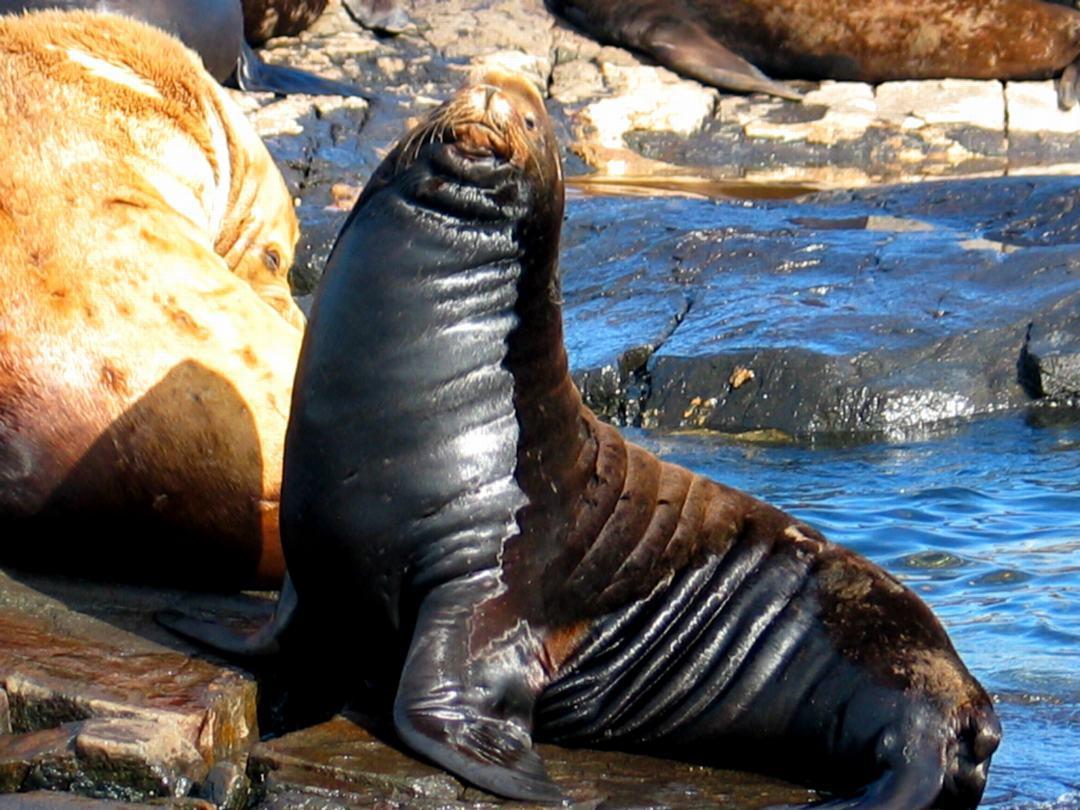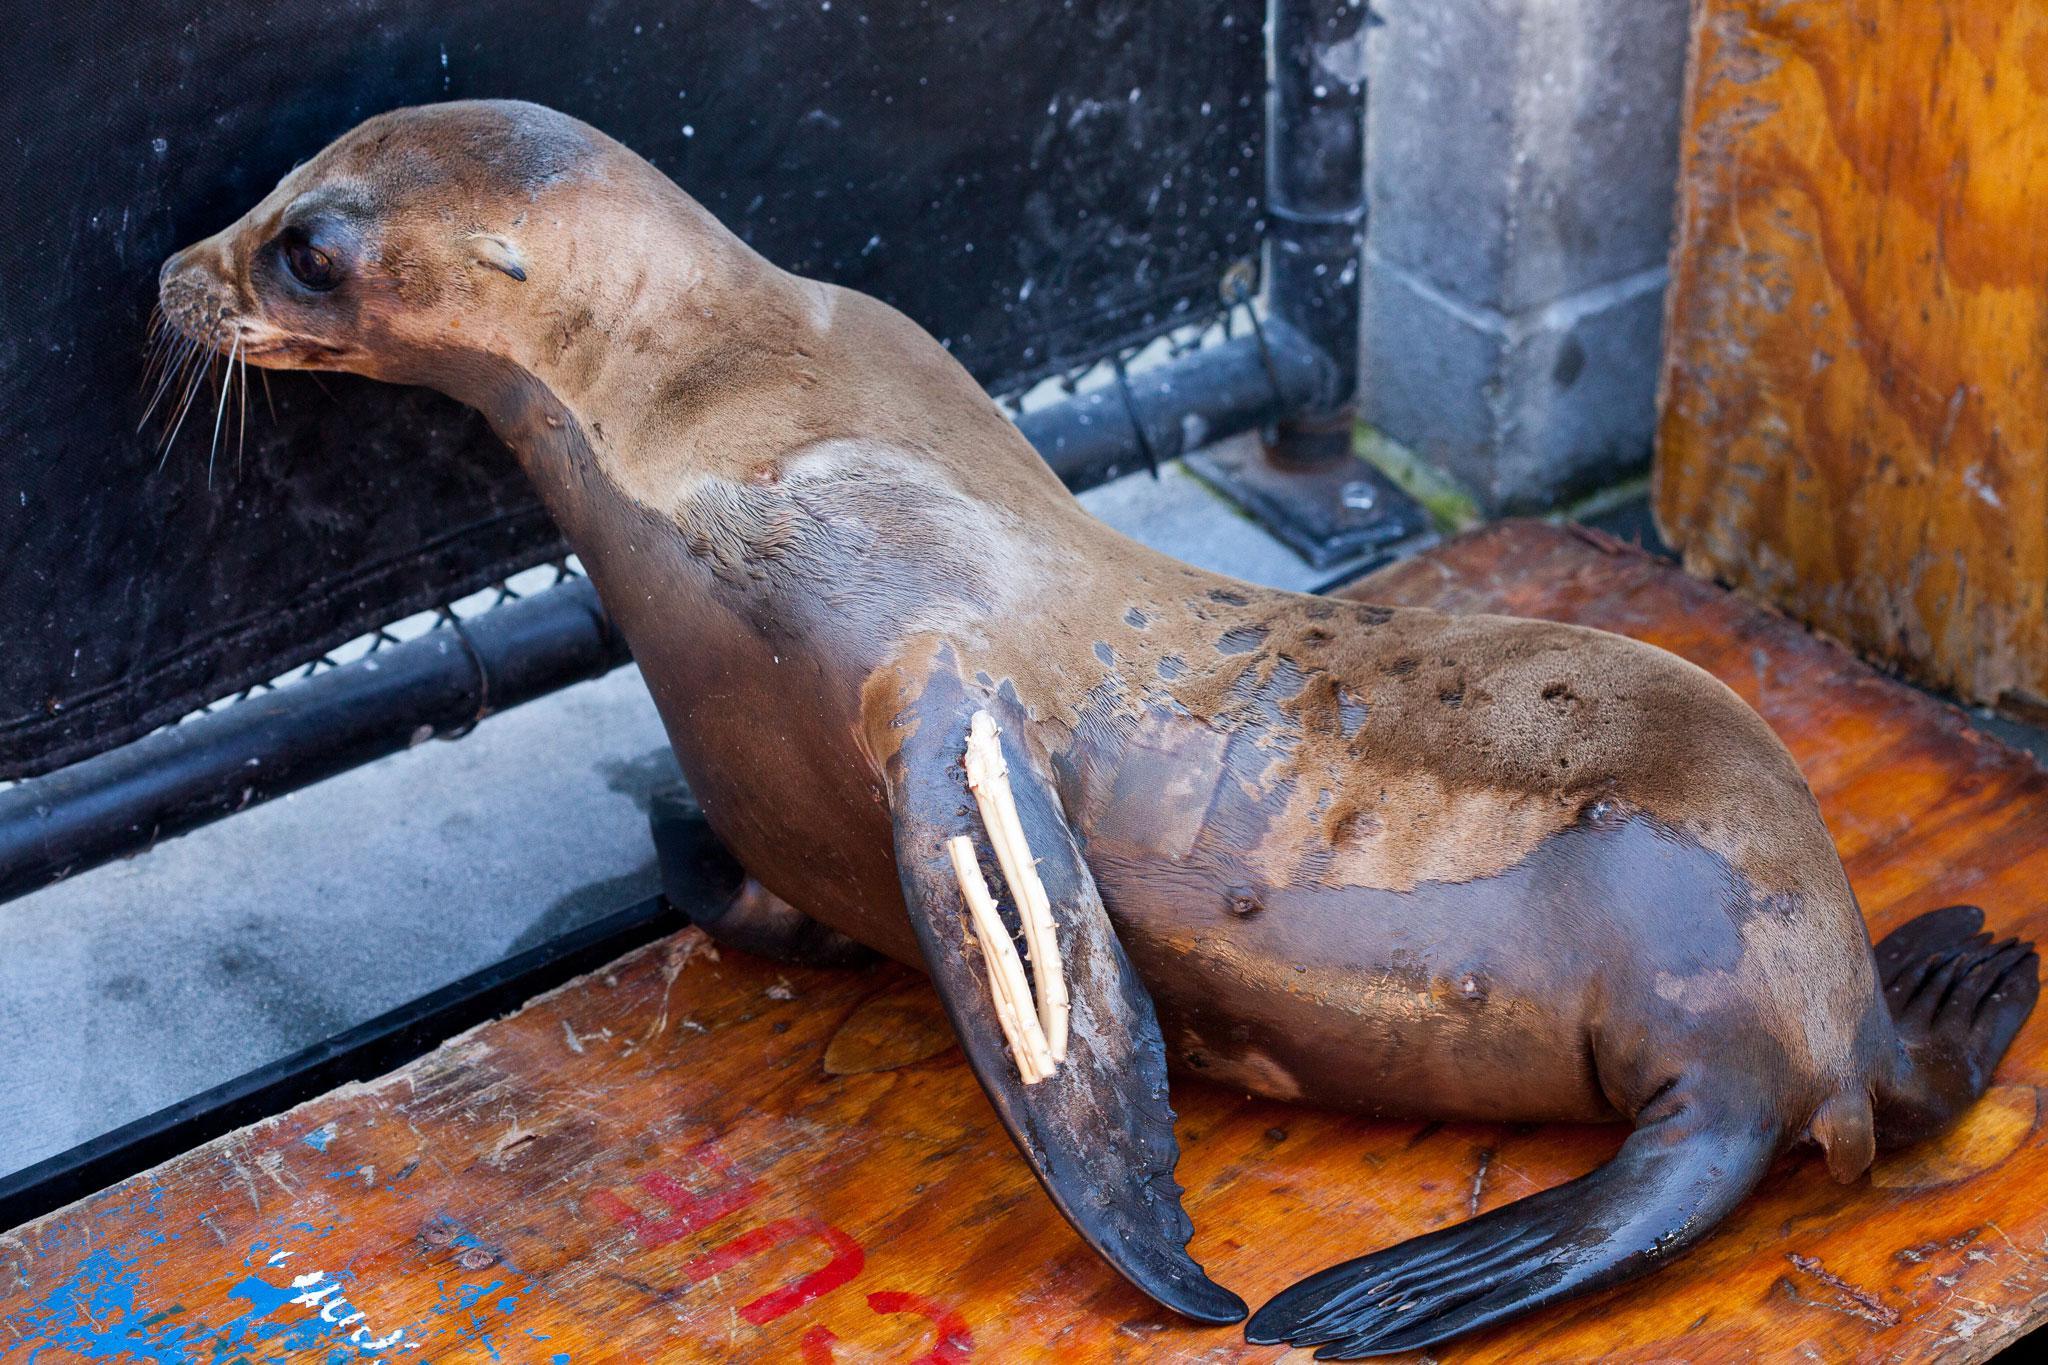The first image is the image on the left, the second image is the image on the right. Considering the images on both sides, is "At least one image includes human interaction with a seal." valid? Answer yes or no. No. 